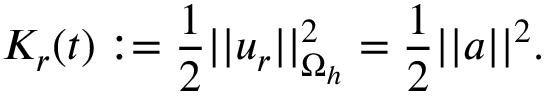Convert formula to latex. <formula><loc_0><loc_0><loc_500><loc_500>K _ { r } ( t ) \colon = \frac { 1 } { 2 } | | u _ { r } | | _ { \Omega _ { h } } ^ { 2 } = \frac { 1 } { 2 } | | a | | ^ { 2 } .</formula> 